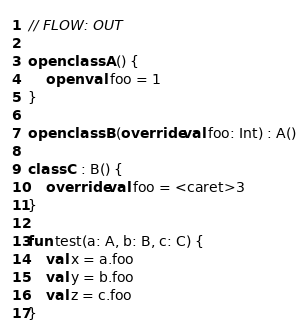Convert code to text. <code><loc_0><loc_0><loc_500><loc_500><_Kotlin_>// FLOW: OUT

open class A() {
    open val foo = 1
}

open class B(override val foo: Int) : A()

class C : B() {
    override val foo = <caret>3
}

fun test(a: A, b: B, c: C) {
    val x = a.foo
    val y = b.foo
    val z = c.foo
}</code> 